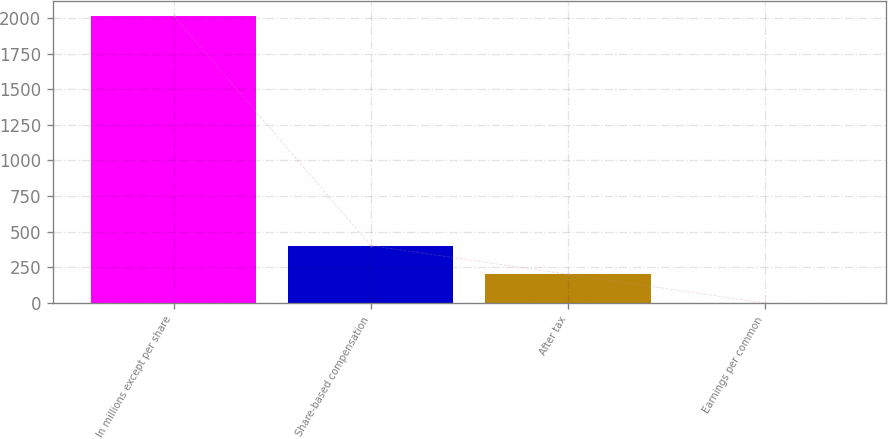Convert chart. <chart><loc_0><loc_0><loc_500><loc_500><bar_chart><fcel>In millions except per share<fcel>Share-based compensation<fcel>After tax<fcel>Earnings per common<nl><fcel>2016<fcel>403.29<fcel>201.7<fcel>0.11<nl></chart> 